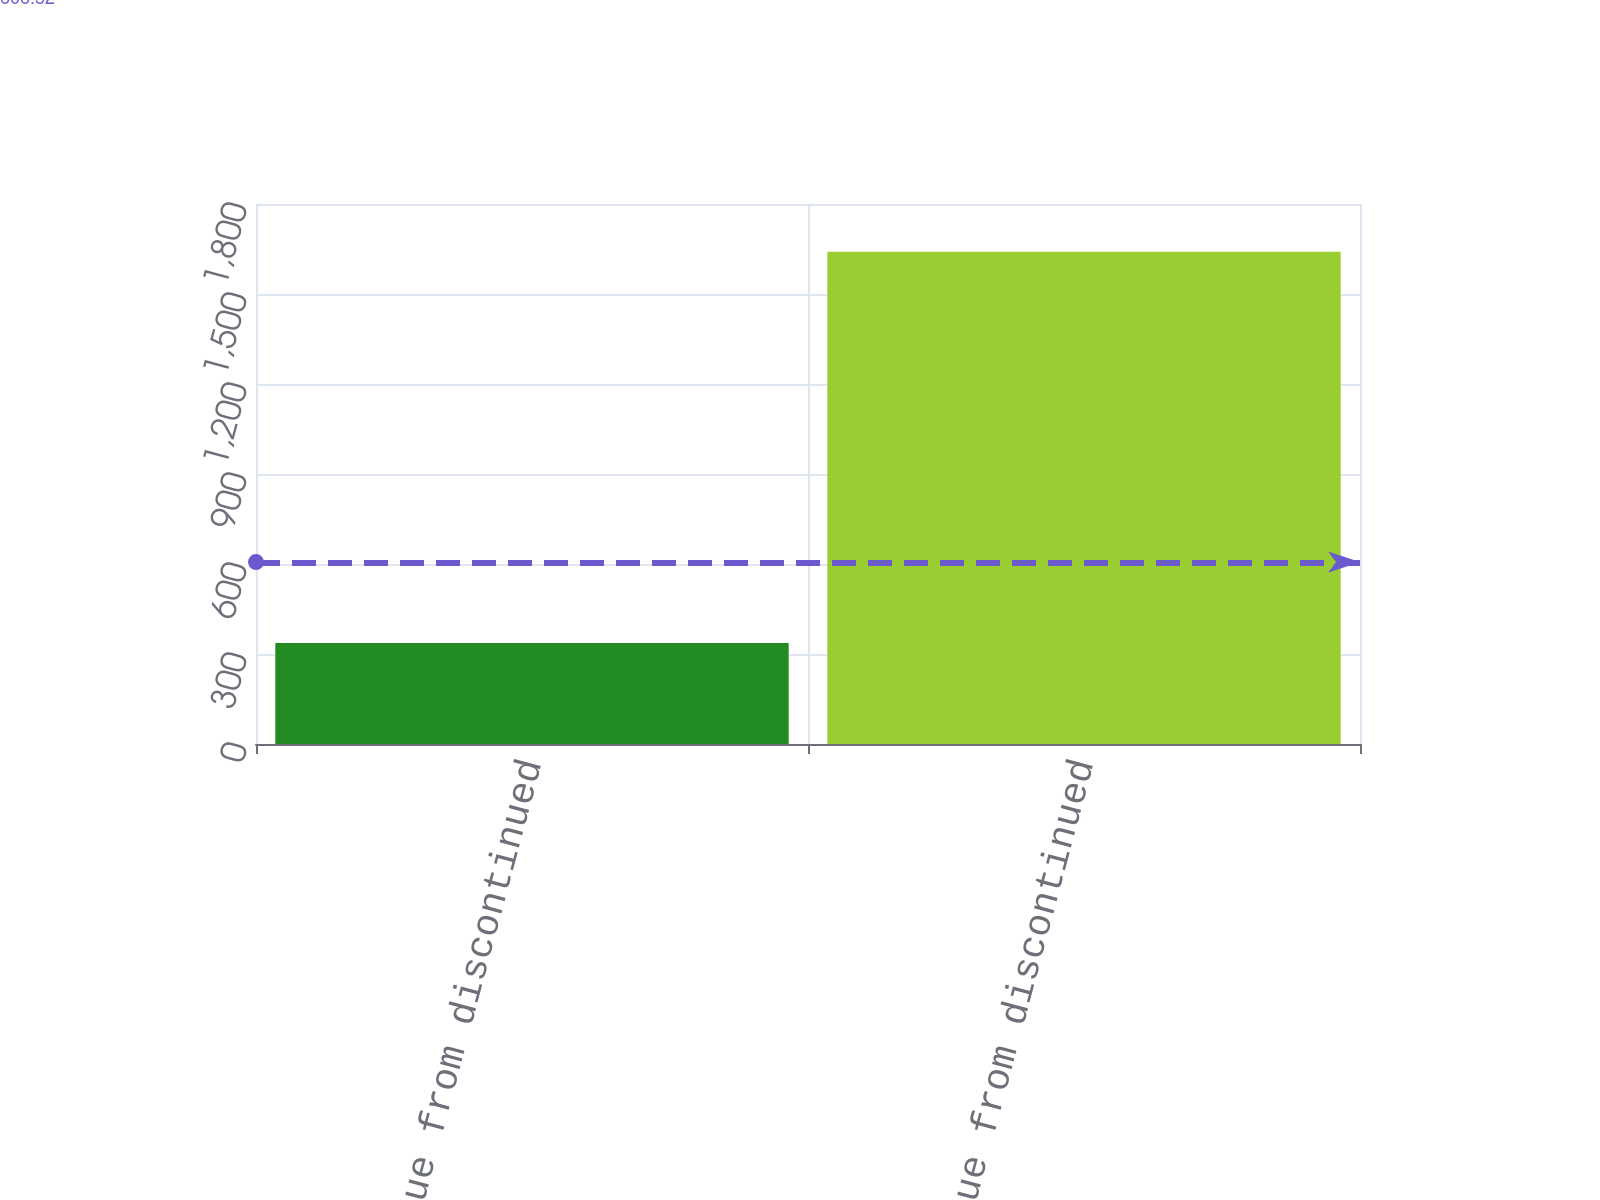Convert chart. <chart><loc_0><loc_0><loc_500><loc_500><bar_chart><fcel>2004 revenue from discontinued<fcel>2003 revenue from discontinued<nl><fcel>337<fcel>1641<nl></chart> 